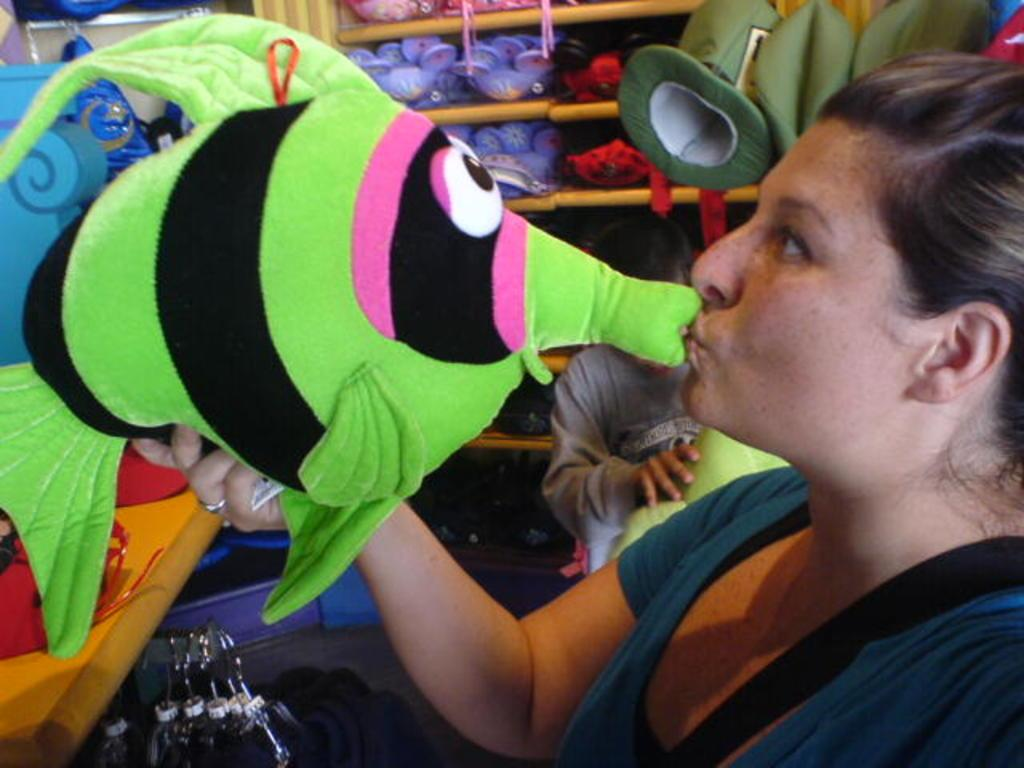How many people are present in the image? There are two persons standing in the image. What is the woman holding in her hand? The woman is holding a green toy in her hand. Can you describe the background of the image? There is a group of toys placed in a rack in the background of the image. What type of fish can be seen swimming in the image? There are no fish present in the image; it features two people and a group of toys. How many snakes are visible in the image? There are no snakes present in the image; it features two people and a group of toys. 